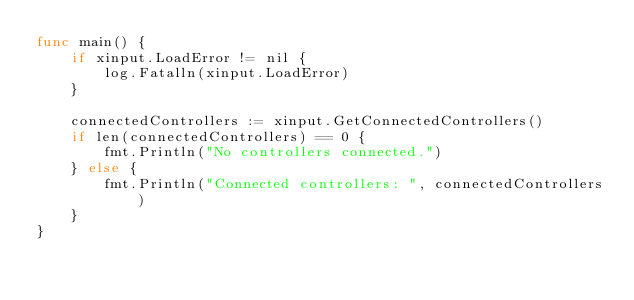Convert code to text. <code><loc_0><loc_0><loc_500><loc_500><_Go_>func main() {
	if xinput.LoadError != nil {
		log.Fatalln(xinput.LoadError)
	}

	connectedControllers := xinput.GetConnectedControllers()
	if len(connectedControllers) == 0 {
		fmt.Println("No controllers connected.")
	} else {
		fmt.Println("Connected controllers: ", connectedControllers)
	}
}
</code> 